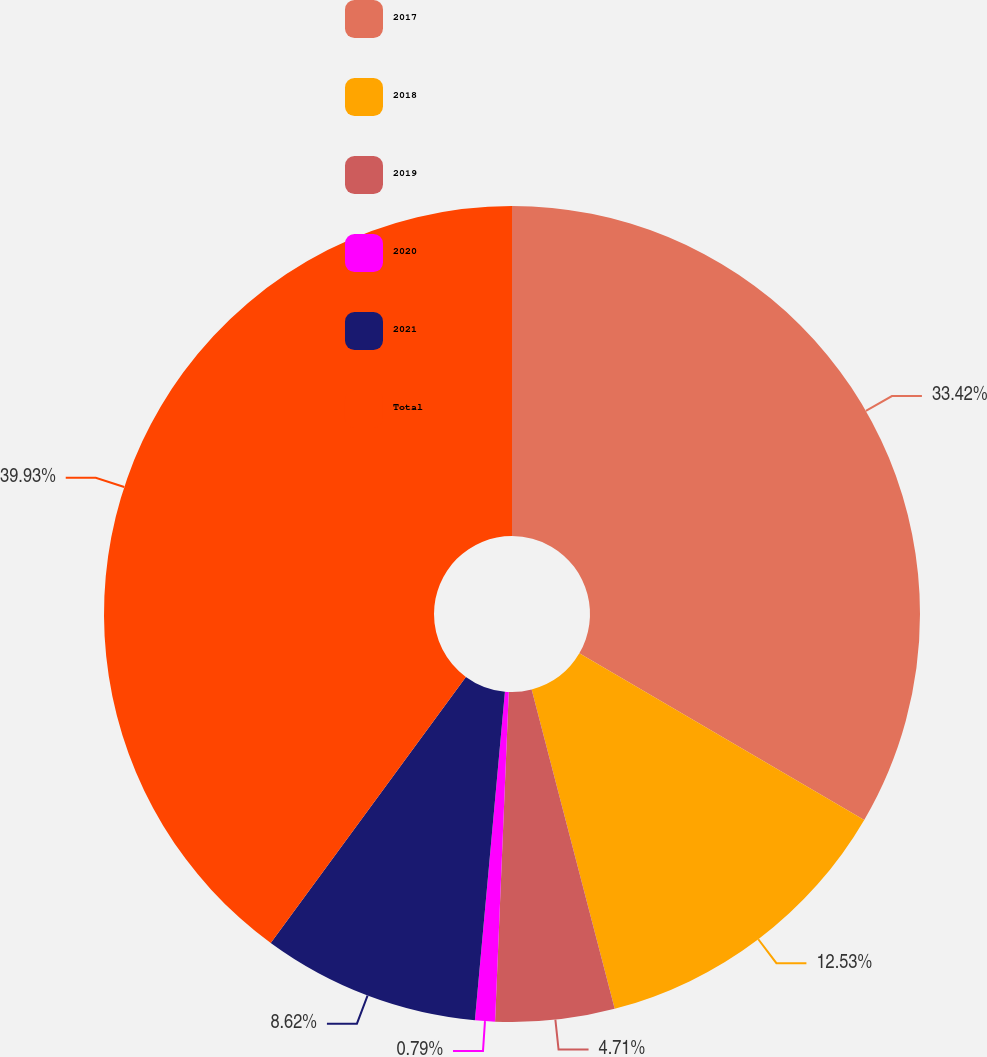Convert chart to OTSL. <chart><loc_0><loc_0><loc_500><loc_500><pie_chart><fcel>2017<fcel>2018<fcel>2019<fcel>2020<fcel>2021<fcel>Total<nl><fcel>33.42%<fcel>12.53%<fcel>4.71%<fcel>0.79%<fcel>8.62%<fcel>39.93%<nl></chart> 